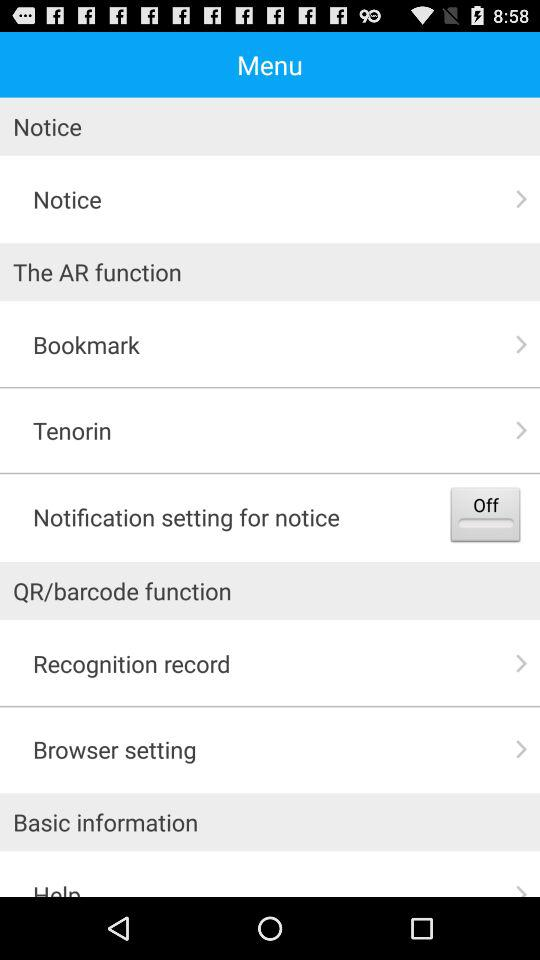What is the status of the "Notification setting for notice"? The status is "off". 